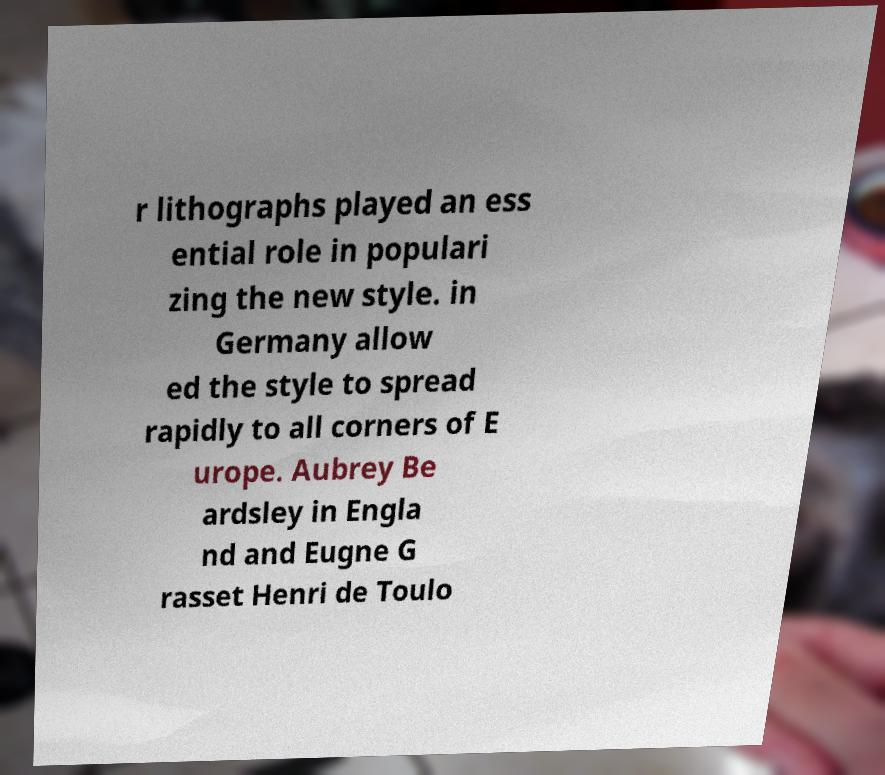What messages or text are displayed in this image? I need them in a readable, typed format. r lithographs played an ess ential role in populari zing the new style. in Germany allow ed the style to spread rapidly to all corners of E urope. Aubrey Be ardsley in Engla nd and Eugne G rasset Henri de Toulo 